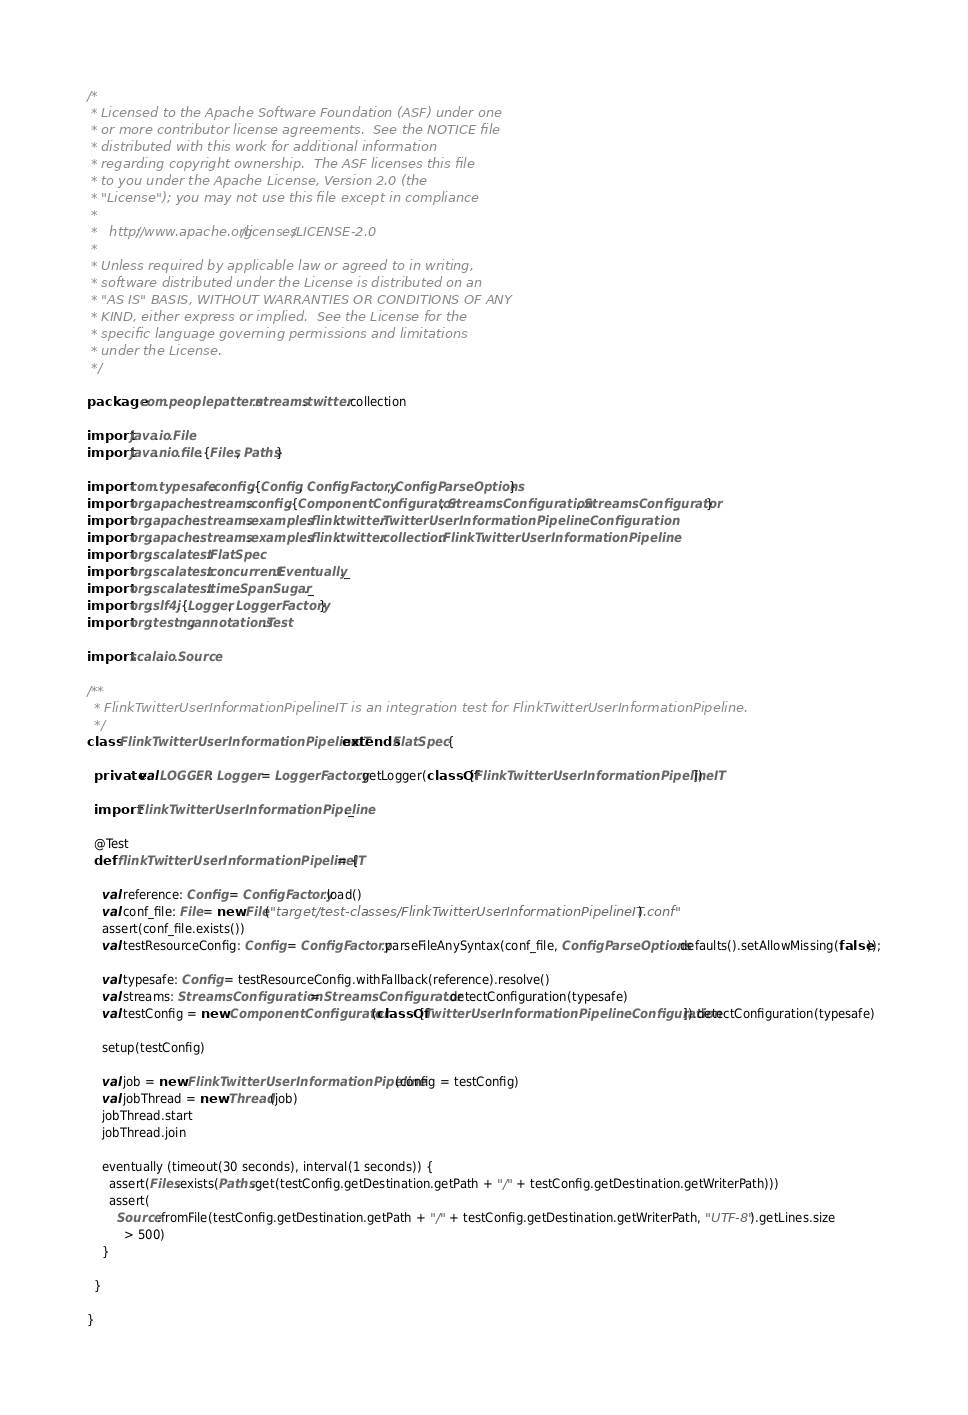Convert code to text. <code><loc_0><loc_0><loc_500><loc_500><_Scala_>/*
 * Licensed to the Apache Software Foundation (ASF) under one
 * or more contributor license agreements.  See the NOTICE file
 * distributed with this work for additional information
 * regarding copyright ownership.  The ASF licenses this file
 * to you under the Apache License, Version 2.0 (the
 * "License"); you may not use this file except in compliance
 *
 *   http://www.apache.org/licenses/LICENSE-2.0
 *
 * Unless required by applicable law or agreed to in writing,
 * software distributed under the License is distributed on an
 * "AS IS" BASIS, WITHOUT WARRANTIES OR CONDITIONS OF ANY
 * KIND, either express or implied.  See the License for the
 * specific language governing permissions and limitations
 * under the License.
 */

package com.peoplepattern.streams.twitter.collection

import java.io.File
import java.nio.file.{Files, Paths}

import com.typesafe.config.{Config, ConfigFactory, ConfigParseOptions}
import org.apache.streams.config.{ComponentConfigurator, StreamsConfiguration, StreamsConfigurator}
import org.apache.streams.examples.flink.twitter.TwitterUserInformationPipelineConfiguration
import org.apache.streams.examples.flink.twitter.collection.FlinkTwitterUserInformationPipeline
import org.scalatest.FlatSpec
import org.scalatest.concurrent.Eventually._
import org.scalatest.time.SpanSugar._
import org.slf4j.{Logger, LoggerFactory}
import org.testng.annotations.Test

import scala.io.Source

/**
  * FlinkTwitterUserInformationPipelineIT is an integration test for FlinkTwitterUserInformationPipeline.
  */
class FlinkTwitterUserInformationPipelineIT extends FlatSpec {

  private val LOGGER: Logger = LoggerFactory.getLogger(classOf[FlinkTwitterUserInformationPipelineIT])

  import FlinkTwitterUserInformationPipeline._

  @Test
  def flinkTwitterUserInformationPipelineIT = {

    val reference: Config = ConfigFactory.load()
    val conf_file: File = new File("target/test-classes/FlinkTwitterUserInformationPipelineIT.conf")
    assert(conf_file.exists())
    val testResourceConfig: Config = ConfigFactory.parseFileAnySyntax(conf_file, ConfigParseOptions.defaults().setAllowMissing(false));

    val typesafe: Config = testResourceConfig.withFallback(reference).resolve()
    val streams: StreamsConfiguration = StreamsConfigurator.detectConfiguration(typesafe)
    val testConfig = new ComponentConfigurator(classOf[TwitterUserInformationPipelineConfiguration]).detectConfiguration(typesafe)

    setup(testConfig)

    val job = new FlinkTwitterUserInformationPipeline(config = testConfig)
    val jobThread = new Thread(job)
    jobThread.start
    jobThread.join

    eventually (timeout(30 seconds), interval(1 seconds)) {
      assert(Files.exists(Paths.get(testConfig.getDestination.getPath + "/" + testConfig.getDestination.getWriterPath)))
      assert(
        Source.fromFile(testConfig.getDestination.getPath + "/" + testConfig.getDestination.getWriterPath, "UTF-8").getLines.size
          > 500)
    }

  }

}
</code> 